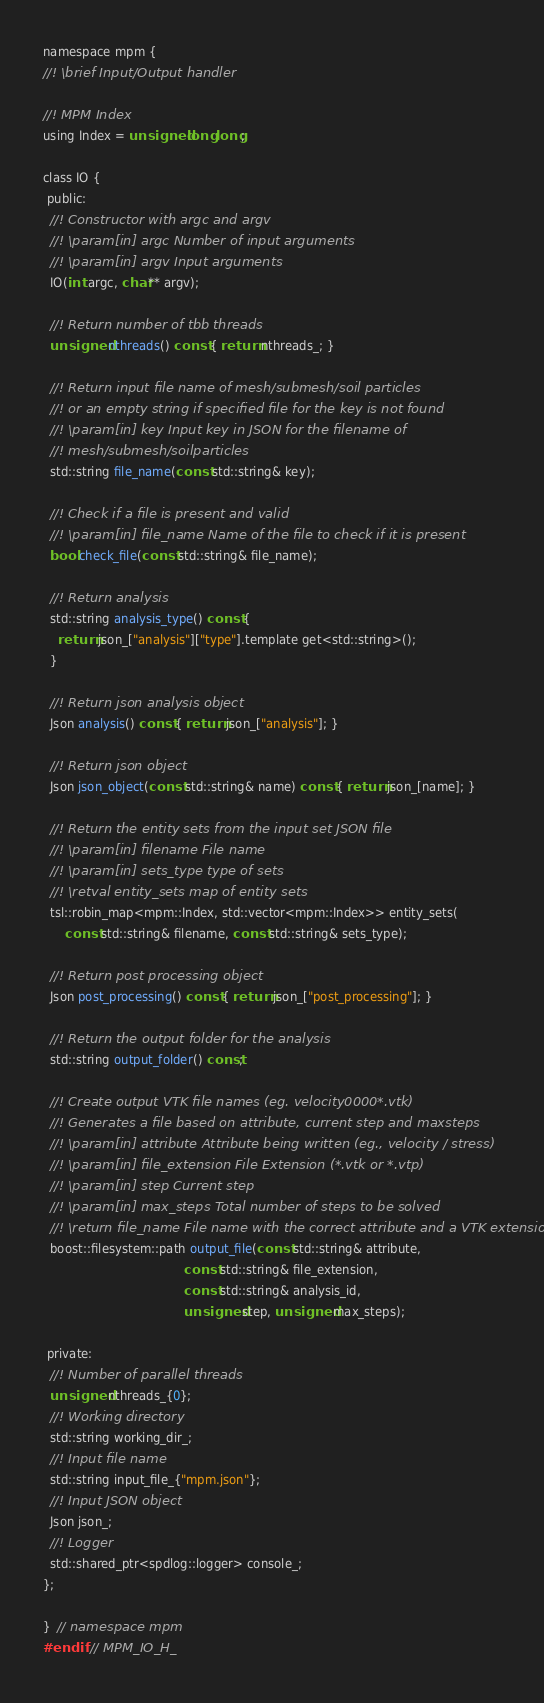Convert code to text. <code><loc_0><loc_0><loc_500><loc_500><_C_>namespace mpm {
//! \brief Input/Output handler

//! MPM Index
using Index = unsigned long long;

class IO {
 public:
  //! Constructor with argc and argv
  //! \param[in] argc Number of input arguments
  //! \param[in] argv Input arguments
  IO(int argc, char** argv);

  //! Return number of tbb threads
  unsigned nthreads() const { return nthreads_; }

  //! Return input file name of mesh/submesh/soil particles
  //! or an empty string if specified file for the key is not found
  //! \param[in] key Input key in JSON for the filename of
  //! mesh/submesh/soilparticles
  std::string file_name(const std::string& key);

  //! Check if a file is present and valid
  //! \param[in] file_name Name of the file to check if it is present
  bool check_file(const std::string& file_name);

  //! Return analysis
  std::string analysis_type() const {
    return json_["analysis"]["type"].template get<std::string>();
  }

  //! Return json analysis object
  Json analysis() const { return json_["analysis"]; }

  //! Return json object
  Json json_object(const std::string& name) const { return json_[name]; }

  //! Return the entity sets from the input set JSON file
  //! \param[in] filename File name
  //! \param[in] sets_type type of sets
  //! \retval entity_sets map of entity sets
  tsl::robin_map<mpm::Index, std::vector<mpm::Index>> entity_sets(
      const std::string& filename, const std::string& sets_type);

  //! Return post processing object
  Json post_processing() const { return json_["post_processing"]; }

  //! Return the output folder for the analysis
  std::string output_folder() const;

  //! Create output VTK file names (eg. velocity0000*.vtk)
  //! Generates a file based on attribute, current step and maxsteps
  //! \param[in] attribute Attribute being written (eg., velocity / stress)
  //! \param[in] file_extension File Extension (*.vtk or *.vtp)
  //! \param[in] step Current step
  //! \param[in] max_steps Total number of steps to be solved
  //! \return file_name File name with the correct attribute and a VTK extension
  boost::filesystem::path output_file(const std::string& attribute,
                                      const std::string& file_extension,
                                      const std::string& analysis_id,
                                      unsigned step, unsigned max_steps);

 private:
  //! Number of parallel threads
  unsigned nthreads_{0};
  //! Working directory
  std::string working_dir_;
  //! Input file name
  std::string input_file_{"mpm.json"};
  //! Input JSON object
  Json json_;
  //! Logger
  std::shared_ptr<spdlog::logger> console_;
};

}  // namespace mpm
#endif  // MPM_IO_H_
</code> 